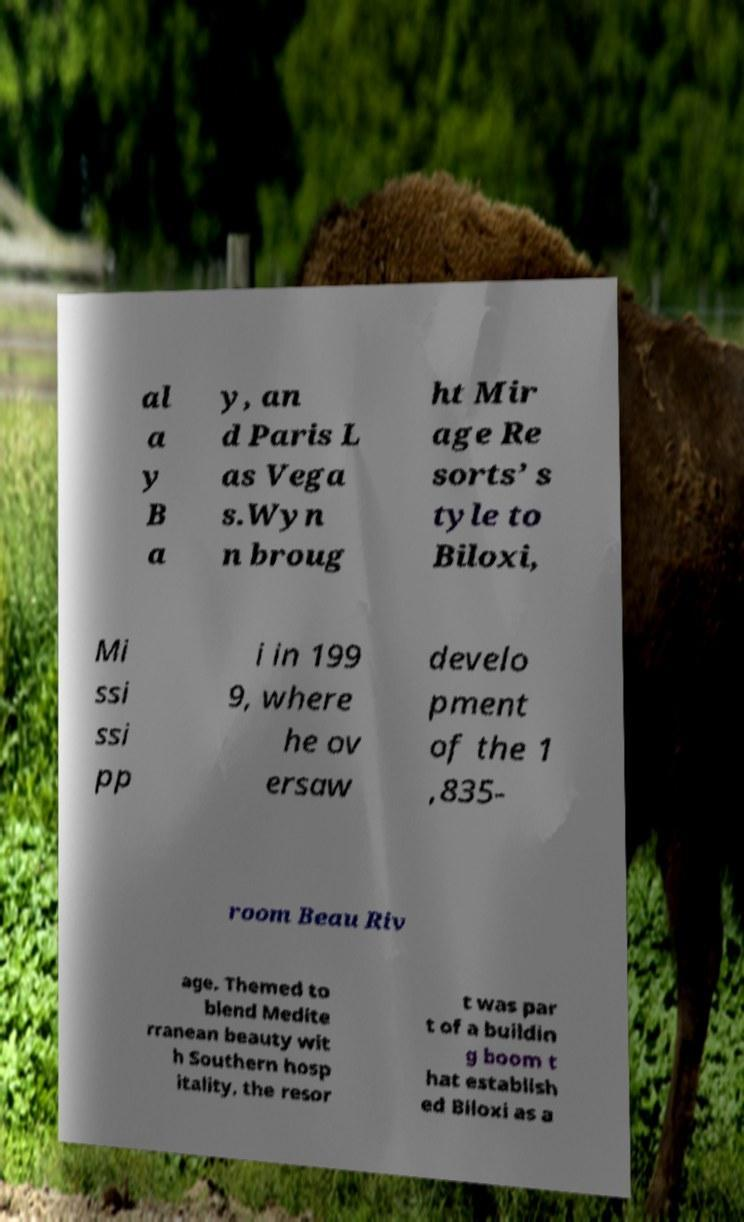I need the written content from this picture converted into text. Can you do that? al a y B a y, an d Paris L as Vega s.Wyn n broug ht Mir age Re sorts’ s tyle to Biloxi, Mi ssi ssi pp i in 199 9, where he ov ersaw develo pment of the 1 ,835- room Beau Riv age. Themed to blend Medite rranean beauty wit h Southern hosp itality, the resor t was par t of a buildin g boom t hat establish ed Biloxi as a 